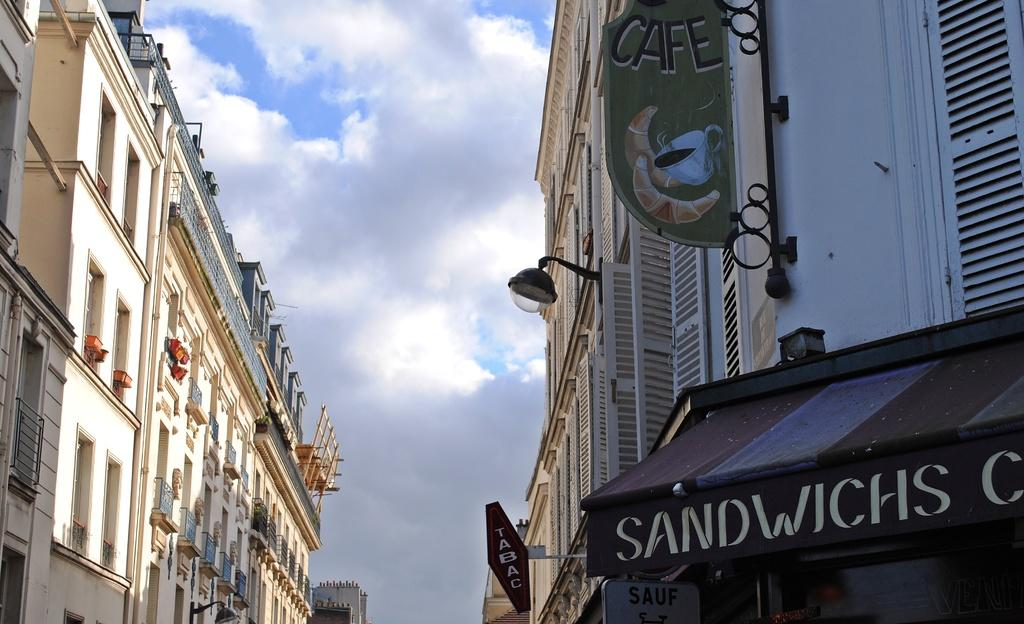What type of structure is visible in the image? There is a building with boards in the image. What object can be seen providing light in the image? There is a lamp in the image. What can be seen on the left side of the image? There are buildings on the left side of the image. What is visible at the top of the image? The sky is visible at the top of the image. How would you describe the sky in the image? The sky appears to be cloudy. What type of jewel can be seen sparkling in the image? There is no jewel present in the image. How does the wind affect the buildings in the image? There is no wind present in the image, and therefore its effect on the buildings cannot be determined. 